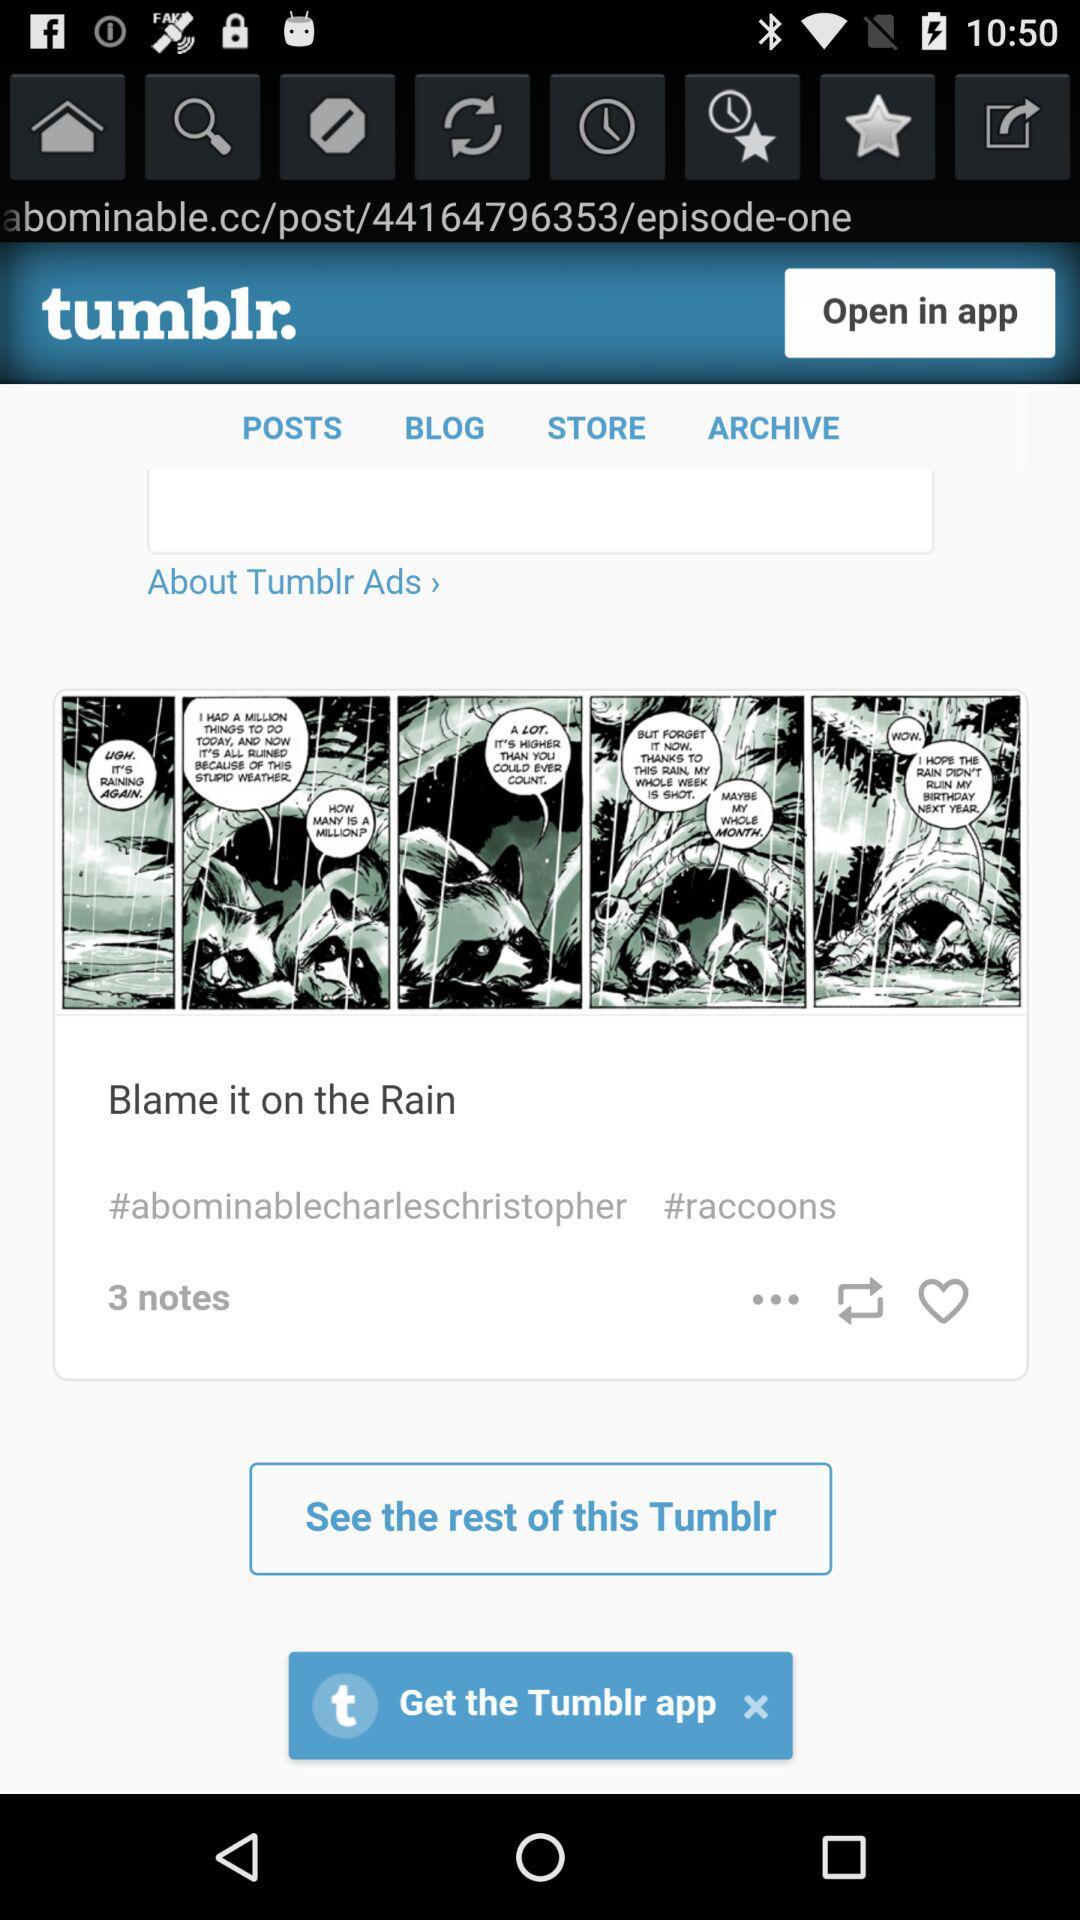What is the name of the episode? The name of the episode is "Blame it on the Rain". 